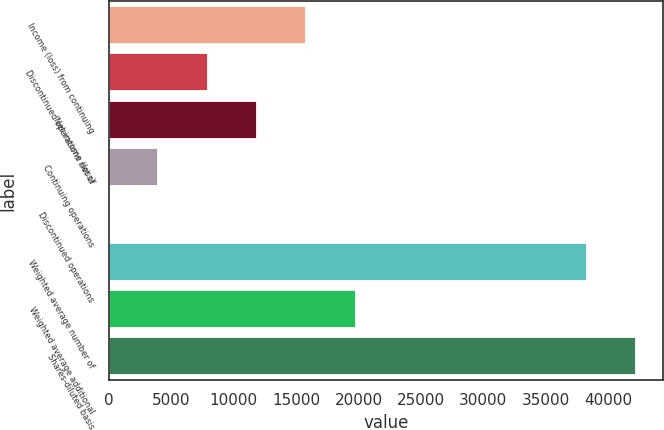<chart> <loc_0><loc_0><loc_500><loc_500><bar_chart><fcel>Income (loss) from continuing<fcel>Discontinued operations net of<fcel>Net income (loss)<fcel>Continuing operations<fcel>Discontinued operations<fcel>Weighted average number of<fcel>Weighted average additional<fcel>Shares-diluted basis<nl><fcel>15815.4<fcel>7907.87<fcel>11861.6<fcel>3954.1<fcel>0.33<fcel>38320<fcel>19769.2<fcel>42273.8<nl></chart> 